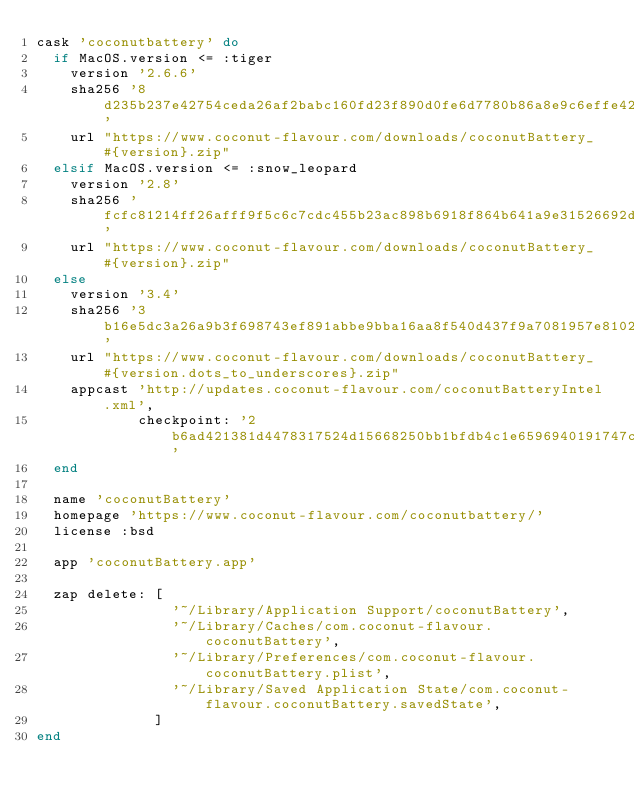<code> <loc_0><loc_0><loc_500><loc_500><_Ruby_>cask 'coconutbattery' do
  if MacOS.version <= :tiger
    version '2.6.6'
    sha256 '8d235b237e42754ceda26af2babc160fd23f890d0fe6d7780b86a8e9c6effe42'
    url "https://www.coconut-flavour.com/downloads/coconutBattery_#{version}.zip"
  elsif MacOS.version <= :snow_leopard
    version '2.8'
    sha256 'fcfc81214ff26afff9f5c6c7cdc455b23ac898b6918f864b641a9e31526692d4'
    url "https://www.coconut-flavour.com/downloads/coconutBattery_#{version}.zip"
  else
    version '3.4'
    sha256 '3b16e5dc3a26a9b3f698743ef891abbe9bba16aa8f540d437f9a7081957e8102'
    url "https://www.coconut-flavour.com/downloads/coconutBattery_#{version.dots_to_underscores}.zip"
    appcast 'http://updates.coconut-flavour.com/coconutBatteryIntel.xml',
            checkpoint: '2b6ad421381d4478317524d15668250bb1bfdb4c1e6596940191747c3386ba1f'
  end

  name 'coconutBattery'
  homepage 'https://www.coconut-flavour.com/coconutbattery/'
  license :bsd

  app 'coconutBattery.app'

  zap delete: [
                '~/Library/Application Support/coconutBattery',
                '~/Library/Caches/com.coconut-flavour.coconutBattery',
                '~/Library/Preferences/com.coconut-flavour.coconutBattery.plist',
                '~/Library/Saved Application State/com.coconut-flavour.coconutBattery.savedState',
              ]
end
</code> 